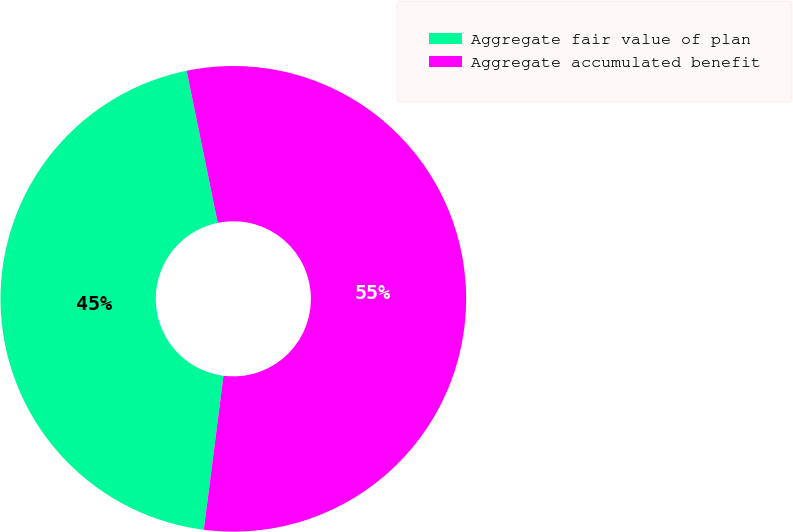<chart> <loc_0><loc_0><loc_500><loc_500><pie_chart><fcel>Aggregate fair value of plan<fcel>Aggregate accumulated benefit<nl><fcel>44.76%<fcel>55.24%<nl></chart> 